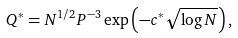Convert formula to latex. <formula><loc_0><loc_0><loc_500><loc_500>Q ^ { * } = N ^ { 1 / 2 } P ^ { - 3 } \exp \left ( - c ^ { * } \sqrt { \log N } \right ) ,</formula> 